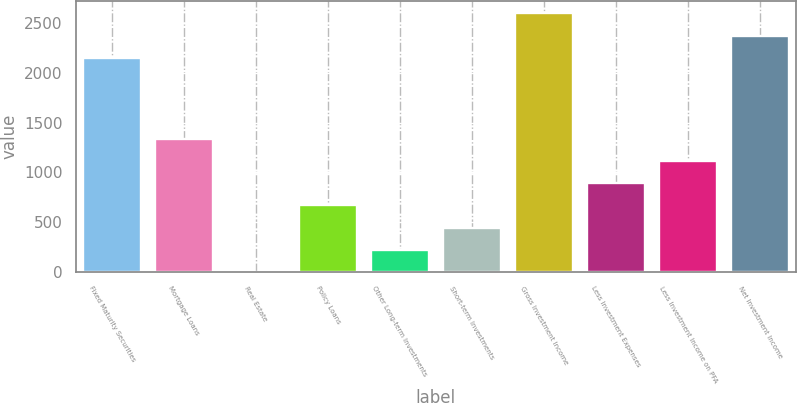Convert chart to OTSL. <chart><loc_0><loc_0><loc_500><loc_500><bar_chart><fcel>Fixed Maturity Securities<fcel>Mortgage Loans<fcel>Real Estate<fcel>Policy Loans<fcel>Other Long-term Investments<fcel>Short-term Investments<fcel>Gross Investment Income<fcel>Less Investment Expenses<fcel>Less Investment Income on PFA<fcel>Net Investment Income<nl><fcel>2151.3<fcel>1339<fcel>0.4<fcel>669.7<fcel>223.5<fcel>446.6<fcel>2597.5<fcel>892.8<fcel>1115.9<fcel>2374.4<nl></chart> 